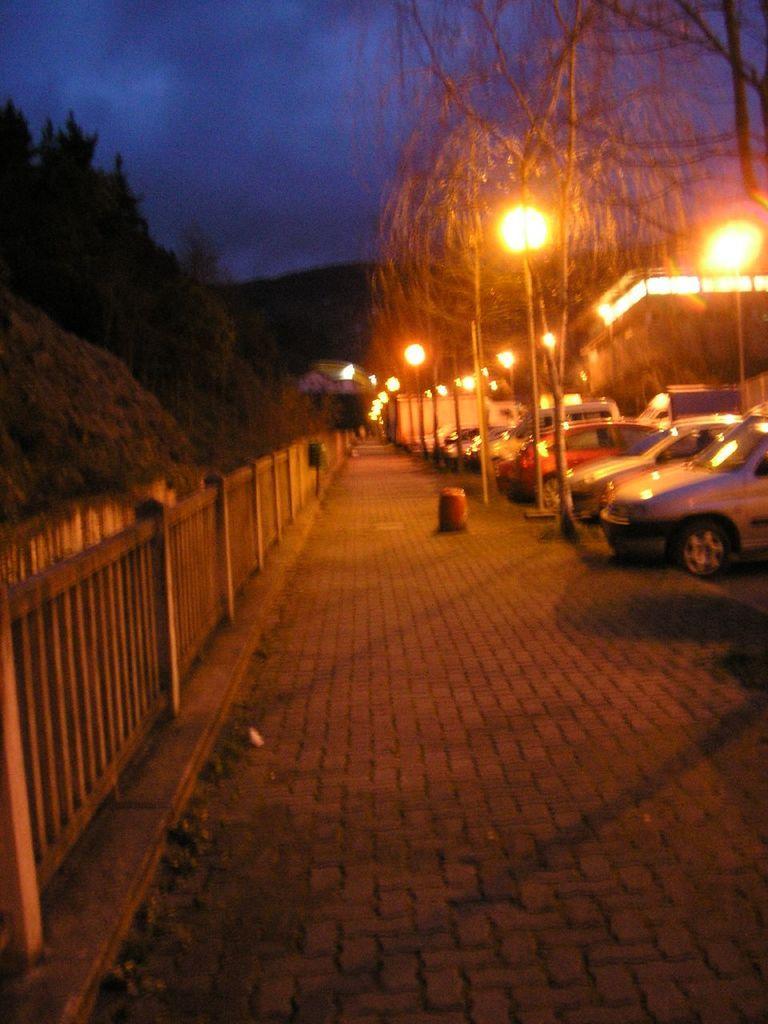Can you describe this image briefly? This picture shows few cars parked and we see few pole lights on the sidewalk and we see trees on the either side and a house and we see a wooden fence and a cloudy sky. 